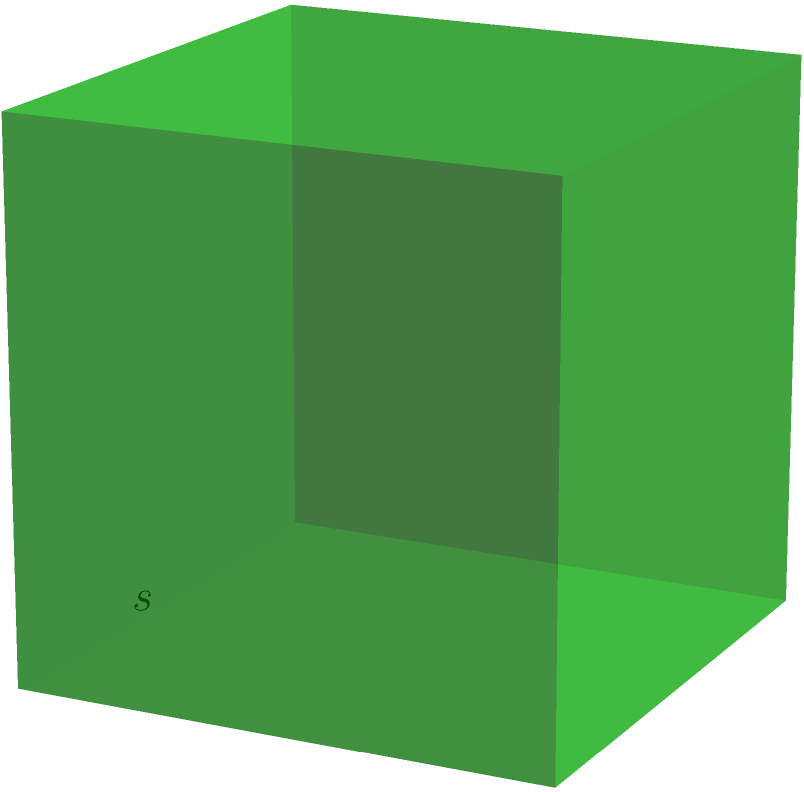For a new film project, you need to calculate the total surface area of a cube-shaped green screen. If each side of the green screen measures 5 meters, what is the total surface area in square meters? Let's approach this step-by-step:

1) First, recall the formula for the surface area of a cube:
   $$ \text{Surface Area} = 6s^2 $$
   where $s$ is the length of one side of the cube.

2) We're given that each side measures 5 meters, so $s = 5$.

3) Let's substitute this into our formula:
   $$ \text{Surface Area} = 6(5^2) $$

4) Now, let's calculate:
   $$ \text{Surface Area} = 6(25) = 150 $$

5) Therefore, the total surface area of the green screen is 150 square meters.

This calculation is crucial for determining the amount of green screen material needed and for planning lighting setups to evenly illuminate the entire surface.
Answer: 150 m² 